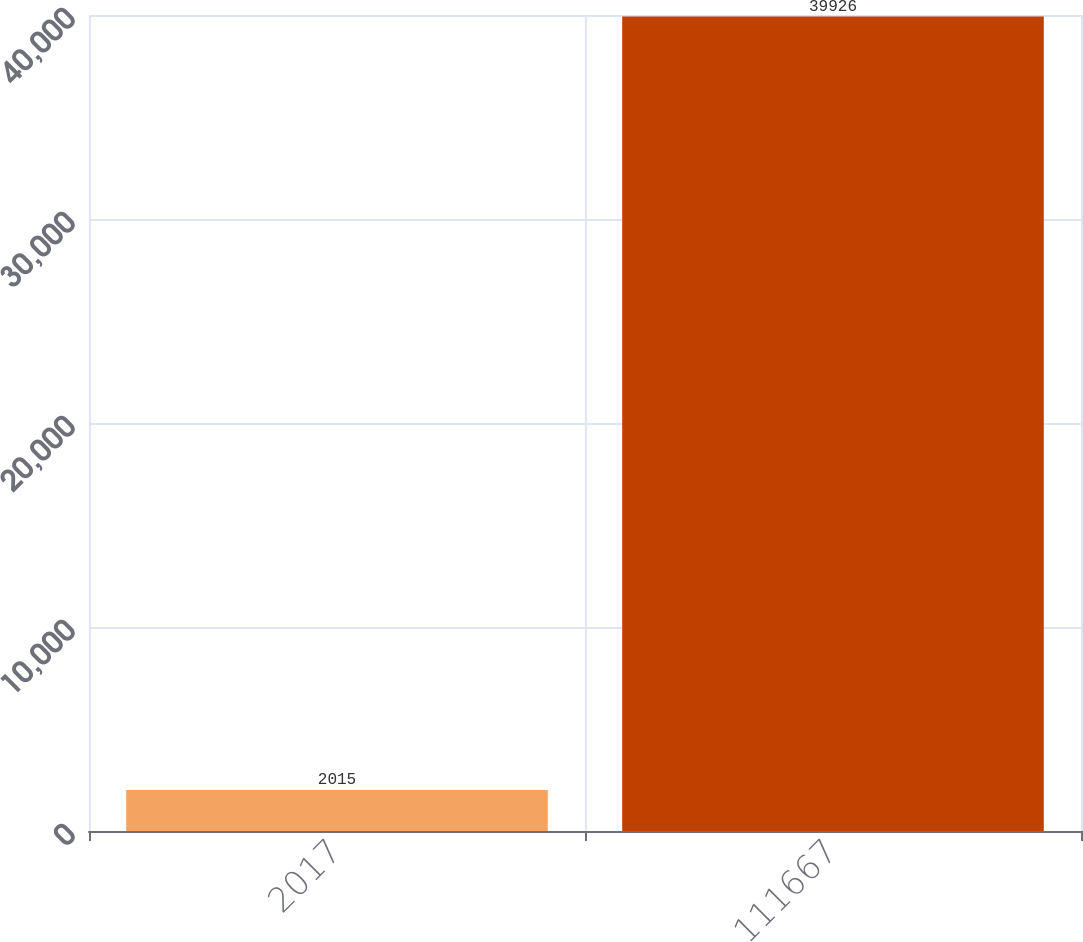<chart> <loc_0><loc_0><loc_500><loc_500><bar_chart><fcel>2017<fcel>111667<nl><fcel>2015<fcel>39926<nl></chart> 